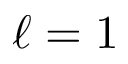<formula> <loc_0><loc_0><loc_500><loc_500>\ell = 1</formula> 